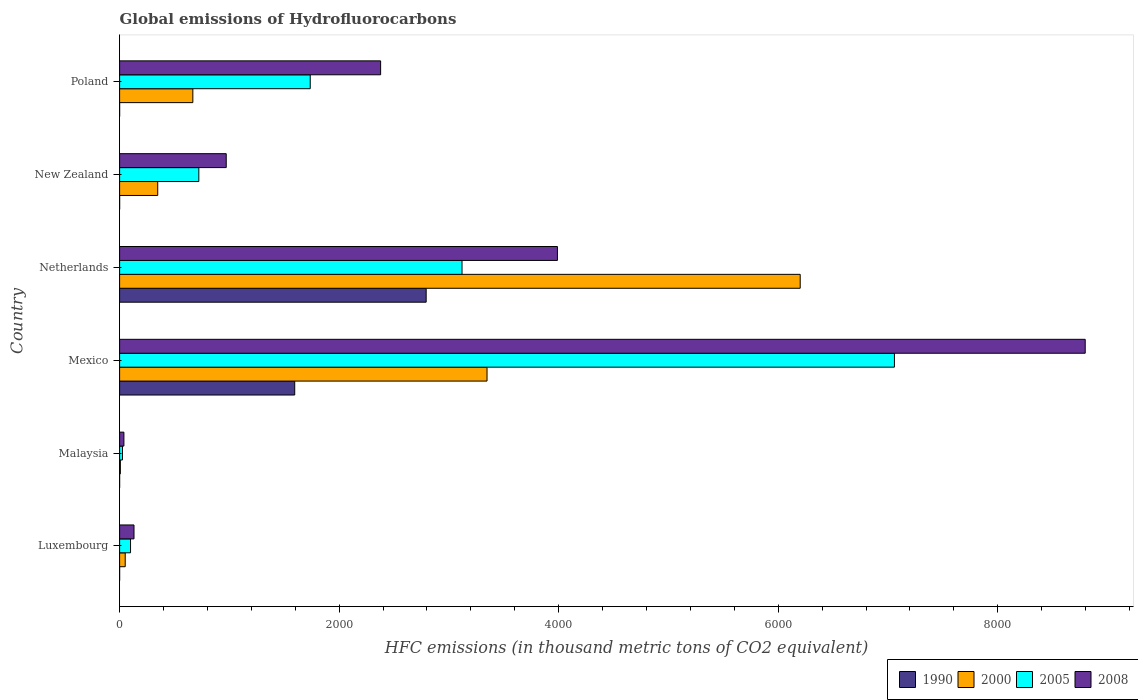What is the label of the 2nd group of bars from the top?
Your response must be concise. New Zealand. What is the global emissions of Hydrofluorocarbons in 2005 in New Zealand?
Provide a succinct answer. 721.7. Across all countries, what is the maximum global emissions of Hydrofluorocarbons in 1990?
Give a very brief answer. 2792.9. In which country was the global emissions of Hydrofluorocarbons in 2005 maximum?
Your response must be concise. Mexico. In which country was the global emissions of Hydrofluorocarbons in 2008 minimum?
Your response must be concise. Malaysia. What is the total global emissions of Hydrofluorocarbons in 2005 in the graph?
Give a very brief answer. 1.28e+04. What is the difference between the global emissions of Hydrofluorocarbons in 2000 in Malaysia and that in New Zealand?
Ensure brevity in your answer.  -340.4. What is the difference between the global emissions of Hydrofluorocarbons in 2005 in Luxembourg and the global emissions of Hydrofluorocarbons in 2000 in New Zealand?
Keep it short and to the point. -247.8. What is the average global emissions of Hydrofluorocarbons in 1990 per country?
Make the answer very short. 731.45. What is the difference between the global emissions of Hydrofluorocarbons in 2005 and global emissions of Hydrofluorocarbons in 2008 in Malaysia?
Your response must be concise. -13.1. What is the ratio of the global emissions of Hydrofluorocarbons in 2000 in Netherlands to that in New Zealand?
Offer a very short reply. 17.85. What is the difference between the highest and the second highest global emissions of Hydrofluorocarbons in 1990?
Your answer should be compact. 1197.6. What is the difference between the highest and the lowest global emissions of Hydrofluorocarbons in 1990?
Your answer should be very brief. 2792.8. In how many countries, is the global emissions of Hydrofluorocarbons in 2008 greater than the average global emissions of Hydrofluorocarbons in 2008 taken over all countries?
Your answer should be very brief. 2. Is the sum of the global emissions of Hydrofluorocarbons in 2008 in Netherlands and Poland greater than the maximum global emissions of Hydrofluorocarbons in 2000 across all countries?
Your answer should be compact. Yes. Is it the case that in every country, the sum of the global emissions of Hydrofluorocarbons in 2008 and global emissions of Hydrofluorocarbons in 2000 is greater than the sum of global emissions of Hydrofluorocarbons in 1990 and global emissions of Hydrofluorocarbons in 2005?
Your response must be concise. No. What does the 1st bar from the top in New Zealand represents?
Give a very brief answer. 2008. How many bars are there?
Provide a succinct answer. 24. Are all the bars in the graph horizontal?
Offer a terse response. Yes. How many countries are there in the graph?
Keep it short and to the point. 6. Are the values on the major ticks of X-axis written in scientific E-notation?
Offer a very short reply. No. Where does the legend appear in the graph?
Your answer should be very brief. Bottom right. How are the legend labels stacked?
Ensure brevity in your answer.  Horizontal. What is the title of the graph?
Keep it short and to the point. Global emissions of Hydrofluorocarbons. Does "2002" appear as one of the legend labels in the graph?
Your response must be concise. No. What is the label or title of the X-axis?
Your answer should be compact. HFC emissions (in thousand metric tons of CO2 equivalent). What is the HFC emissions (in thousand metric tons of CO2 equivalent) in 1990 in Luxembourg?
Your answer should be very brief. 0.1. What is the HFC emissions (in thousand metric tons of CO2 equivalent) of 2000 in Luxembourg?
Your response must be concise. 51.1. What is the HFC emissions (in thousand metric tons of CO2 equivalent) of 2005 in Luxembourg?
Your answer should be very brief. 99.5. What is the HFC emissions (in thousand metric tons of CO2 equivalent) in 2008 in Luxembourg?
Give a very brief answer. 131.2. What is the HFC emissions (in thousand metric tons of CO2 equivalent) in 1990 in Malaysia?
Provide a short and direct response. 0.1. What is the HFC emissions (in thousand metric tons of CO2 equivalent) of 2005 in Malaysia?
Provide a succinct answer. 26.1. What is the HFC emissions (in thousand metric tons of CO2 equivalent) of 2008 in Malaysia?
Ensure brevity in your answer.  39.2. What is the HFC emissions (in thousand metric tons of CO2 equivalent) in 1990 in Mexico?
Give a very brief answer. 1595.3. What is the HFC emissions (in thousand metric tons of CO2 equivalent) of 2000 in Mexico?
Provide a short and direct response. 3347.3. What is the HFC emissions (in thousand metric tons of CO2 equivalent) in 2005 in Mexico?
Give a very brief answer. 7058.9. What is the HFC emissions (in thousand metric tons of CO2 equivalent) of 2008 in Mexico?
Provide a short and direct response. 8796.9. What is the HFC emissions (in thousand metric tons of CO2 equivalent) of 1990 in Netherlands?
Make the answer very short. 2792.9. What is the HFC emissions (in thousand metric tons of CO2 equivalent) in 2000 in Netherlands?
Keep it short and to the point. 6200.4. What is the HFC emissions (in thousand metric tons of CO2 equivalent) of 2005 in Netherlands?
Your response must be concise. 3119.5. What is the HFC emissions (in thousand metric tons of CO2 equivalent) of 2008 in Netherlands?
Offer a terse response. 3988.8. What is the HFC emissions (in thousand metric tons of CO2 equivalent) in 2000 in New Zealand?
Give a very brief answer. 347.3. What is the HFC emissions (in thousand metric tons of CO2 equivalent) of 2005 in New Zealand?
Your answer should be very brief. 721.7. What is the HFC emissions (in thousand metric tons of CO2 equivalent) of 2008 in New Zealand?
Your answer should be very brief. 971.4. What is the HFC emissions (in thousand metric tons of CO2 equivalent) in 2000 in Poland?
Offer a terse response. 667.2. What is the HFC emissions (in thousand metric tons of CO2 equivalent) of 2005 in Poland?
Give a very brief answer. 1736.7. What is the HFC emissions (in thousand metric tons of CO2 equivalent) in 2008 in Poland?
Your answer should be compact. 2378. Across all countries, what is the maximum HFC emissions (in thousand metric tons of CO2 equivalent) of 1990?
Give a very brief answer. 2792.9. Across all countries, what is the maximum HFC emissions (in thousand metric tons of CO2 equivalent) in 2000?
Ensure brevity in your answer.  6200.4. Across all countries, what is the maximum HFC emissions (in thousand metric tons of CO2 equivalent) in 2005?
Make the answer very short. 7058.9. Across all countries, what is the maximum HFC emissions (in thousand metric tons of CO2 equivalent) in 2008?
Your response must be concise. 8796.9. Across all countries, what is the minimum HFC emissions (in thousand metric tons of CO2 equivalent) of 2005?
Your response must be concise. 26.1. Across all countries, what is the minimum HFC emissions (in thousand metric tons of CO2 equivalent) of 2008?
Provide a short and direct response. 39.2. What is the total HFC emissions (in thousand metric tons of CO2 equivalent) of 1990 in the graph?
Provide a succinct answer. 4388.7. What is the total HFC emissions (in thousand metric tons of CO2 equivalent) in 2000 in the graph?
Offer a terse response. 1.06e+04. What is the total HFC emissions (in thousand metric tons of CO2 equivalent) of 2005 in the graph?
Ensure brevity in your answer.  1.28e+04. What is the total HFC emissions (in thousand metric tons of CO2 equivalent) in 2008 in the graph?
Offer a terse response. 1.63e+04. What is the difference between the HFC emissions (in thousand metric tons of CO2 equivalent) of 1990 in Luxembourg and that in Malaysia?
Offer a very short reply. 0. What is the difference between the HFC emissions (in thousand metric tons of CO2 equivalent) in 2000 in Luxembourg and that in Malaysia?
Provide a short and direct response. 44.2. What is the difference between the HFC emissions (in thousand metric tons of CO2 equivalent) of 2005 in Luxembourg and that in Malaysia?
Your answer should be compact. 73.4. What is the difference between the HFC emissions (in thousand metric tons of CO2 equivalent) in 2008 in Luxembourg and that in Malaysia?
Your answer should be compact. 92. What is the difference between the HFC emissions (in thousand metric tons of CO2 equivalent) in 1990 in Luxembourg and that in Mexico?
Provide a short and direct response. -1595.2. What is the difference between the HFC emissions (in thousand metric tons of CO2 equivalent) of 2000 in Luxembourg and that in Mexico?
Your answer should be very brief. -3296.2. What is the difference between the HFC emissions (in thousand metric tons of CO2 equivalent) in 2005 in Luxembourg and that in Mexico?
Provide a succinct answer. -6959.4. What is the difference between the HFC emissions (in thousand metric tons of CO2 equivalent) of 2008 in Luxembourg and that in Mexico?
Make the answer very short. -8665.7. What is the difference between the HFC emissions (in thousand metric tons of CO2 equivalent) of 1990 in Luxembourg and that in Netherlands?
Ensure brevity in your answer.  -2792.8. What is the difference between the HFC emissions (in thousand metric tons of CO2 equivalent) in 2000 in Luxembourg and that in Netherlands?
Provide a short and direct response. -6149.3. What is the difference between the HFC emissions (in thousand metric tons of CO2 equivalent) of 2005 in Luxembourg and that in Netherlands?
Provide a short and direct response. -3020. What is the difference between the HFC emissions (in thousand metric tons of CO2 equivalent) of 2008 in Luxembourg and that in Netherlands?
Keep it short and to the point. -3857.6. What is the difference between the HFC emissions (in thousand metric tons of CO2 equivalent) in 2000 in Luxembourg and that in New Zealand?
Offer a very short reply. -296.2. What is the difference between the HFC emissions (in thousand metric tons of CO2 equivalent) of 2005 in Luxembourg and that in New Zealand?
Provide a succinct answer. -622.2. What is the difference between the HFC emissions (in thousand metric tons of CO2 equivalent) in 2008 in Luxembourg and that in New Zealand?
Give a very brief answer. -840.2. What is the difference between the HFC emissions (in thousand metric tons of CO2 equivalent) in 1990 in Luxembourg and that in Poland?
Keep it short and to the point. 0. What is the difference between the HFC emissions (in thousand metric tons of CO2 equivalent) in 2000 in Luxembourg and that in Poland?
Offer a terse response. -616.1. What is the difference between the HFC emissions (in thousand metric tons of CO2 equivalent) of 2005 in Luxembourg and that in Poland?
Provide a succinct answer. -1637.2. What is the difference between the HFC emissions (in thousand metric tons of CO2 equivalent) in 2008 in Luxembourg and that in Poland?
Your response must be concise. -2246.8. What is the difference between the HFC emissions (in thousand metric tons of CO2 equivalent) of 1990 in Malaysia and that in Mexico?
Ensure brevity in your answer.  -1595.2. What is the difference between the HFC emissions (in thousand metric tons of CO2 equivalent) of 2000 in Malaysia and that in Mexico?
Ensure brevity in your answer.  -3340.4. What is the difference between the HFC emissions (in thousand metric tons of CO2 equivalent) in 2005 in Malaysia and that in Mexico?
Your answer should be compact. -7032.8. What is the difference between the HFC emissions (in thousand metric tons of CO2 equivalent) in 2008 in Malaysia and that in Mexico?
Provide a succinct answer. -8757.7. What is the difference between the HFC emissions (in thousand metric tons of CO2 equivalent) in 1990 in Malaysia and that in Netherlands?
Ensure brevity in your answer.  -2792.8. What is the difference between the HFC emissions (in thousand metric tons of CO2 equivalent) of 2000 in Malaysia and that in Netherlands?
Keep it short and to the point. -6193.5. What is the difference between the HFC emissions (in thousand metric tons of CO2 equivalent) of 2005 in Malaysia and that in Netherlands?
Your answer should be compact. -3093.4. What is the difference between the HFC emissions (in thousand metric tons of CO2 equivalent) in 2008 in Malaysia and that in Netherlands?
Provide a succinct answer. -3949.6. What is the difference between the HFC emissions (in thousand metric tons of CO2 equivalent) of 2000 in Malaysia and that in New Zealand?
Keep it short and to the point. -340.4. What is the difference between the HFC emissions (in thousand metric tons of CO2 equivalent) of 2005 in Malaysia and that in New Zealand?
Provide a short and direct response. -695.6. What is the difference between the HFC emissions (in thousand metric tons of CO2 equivalent) in 2008 in Malaysia and that in New Zealand?
Ensure brevity in your answer.  -932.2. What is the difference between the HFC emissions (in thousand metric tons of CO2 equivalent) of 2000 in Malaysia and that in Poland?
Offer a terse response. -660.3. What is the difference between the HFC emissions (in thousand metric tons of CO2 equivalent) of 2005 in Malaysia and that in Poland?
Offer a very short reply. -1710.6. What is the difference between the HFC emissions (in thousand metric tons of CO2 equivalent) in 2008 in Malaysia and that in Poland?
Keep it short and to the point. -2338.8. What is the difference between the HFC emissions (in thousand metric tons of CO2 equivalent) of 1990 in Mexico and that in Netherlands?
Provide a short and direct response. -1197.6. What is the difference between the HFC emissions (in thousand metric tons of CO2 equivalent) of 2000 in Mexico and that in Netherlands?
Offer a terse response. -2853.1. What is the difference between the HFC emissions (in thousand metric tons of CO2 equivalent) in 2005 in Mexico and that in Netherlands?
Provide a succinct answer. 3939.4. What is the difference between the HFC emissions (in thousand metric tons of CO2 equivalent) in 2008 in Mexico and that in Netherlands?
Make the answer very short. 4808.1. What is the difference between the HFC emissions (in thousand metric tons of CO2 equivalent) in 1990 in Mexico and that in New Zealand?
Offer a terse response. 1595.1. What is the difference between the HFC emissions (in thousand metric tons of CO2 equivalent) of 2000 in Mexico and that in New Zealand?
Give a very brief answer. 3000. What is the difference between the HFC emissions (in thousand metric tons of CO2 equivalent) of 2005 in Mexico and that in New Zealand?
Your answer should be very brief. 6337.2. What is the difference between the HFC emissions (in thousand metric tons of CO2 equivalent) of 2008 in Mexico and that in New Zealand?
Your response must be concise. 7825.5. What is the difference between the HFC emissions (in thousand metric tons of CO2 equivalent) of 1990 in Mexico and that in Poland?
Your answer should be very brief. 1595.2. What is the difference between the HFC emissions (in thousand metric tons of CO2 equivalent) in 2000 in Mexico and that in Poland?
Your answer should be compact. 2680.1. What is the difference between the HFC emissions (in thousand metric tons of CO2 equivalent) in 2005 in Mexico and that in Poland?
Provide a succinct answer. 5322.2. What is the difference between the HFC emissions (in thousand metric tons of CO2 equivalent) of 2008 in Mexico and that in Poland?
Offer a terse response. 6418.9. What is the difference between the HFC emissions (in thousand metric tons of CO2 equivalent) in 1990 in Netherlands and that in New Zealand?
Offer a terse response. 2792.7. What is the difference between the HFC emissions (in thousand metric tons of CO2 equivalent) of 2000 in Netherlands and that in New Zealand?
Offer a very short reply. 5853.1. What is the difference between the HFC emissions (in thousand metric tons of CO2 equivalent) in 2005 in Netherlands and that in New Zealand?
Keep it short and to the point. 2397.8. What is the difference between the HFC emissions (in thousand metric tons of CO2 equivalent) of 2008 in Netherlands and that in New Zealand?
Ensure brevity in your answer.  3017.4. What is the difference between the HFC emissions (in thousand metric tons of CO2 equivalent) of 1990 in Netherlands and that in Poland?
Your response must be concise. 2792.8. What is the difference between the HFC emissions (in thousand metric tons of CO2 equivalent) of 2000 in Netherlands and that in Poland?
Give a very brief answer. 5533.2. What is the difference between the HFC emissions (in thousand metric tons of CO2 equivalent) in 2005 in Netherlands and that in Poland?
Offer a very short reply. 1382.8. What is the difference between the HFC emissions (in thousand metric tons of CO2 equivalent) in 2008 in Netherlands and that in Poland?
Your response must be concise. 1610.8. What is the difference between the HFC emissions (in thousand metric tons of CO2 equivalent) of 2000 in New Zealand and that in Poland?
Provide a short and direct response. -319.9. What is the difference between the HFC emissions (in thousand metric tons of CO2 equivalent) of 2005 in New Zealand and that in Poland?
Ensure brevity in your answer.  -1015. What is the difference between the HFC emissions (in thousand metric tons of CO2 equivalent) of 2008 in New Zealand and that in Poland?
Your response must be concise. -1406.6. What is the difference between the HFC emissions (in thousand metric tons of CO2 equivalent) of 1990 in Luxembourg and the HFC emissions (in thousand metric tons of CO2 equivalent) of 2000 in Malaysia?
Give a very brief answer. -6.8. What is the difference between the HFC emissions (in thousand metric tons of CO2 equivalent) in 1990 in Luxembourg and the HFC emissions (in thousand metric tons of CO2 equivalent) in 2005 in Malaysia?
Your answer should be compact. -26. What is the difference between the HFC emissions (in thousand metric tons of CO2 equivalent) of 1990 in Luxembourg and the HFC emissions (in thousand metric tons of CO2 equivalent) of 2008 in Malaysia?
Keep it short and to the point. -39.1. What is the difference between the HFC emissions (in thousand metric tons of CO2 equivalent) of 2000 in Luxembourg and the HFC emissions (in thousand metric tons of CO2 equivalent) of 2005 in Malaysia?
Make the answer very short. 25. What is the difference between the HFC emissions (in thousand metric tons of CO2 equivalent) in 2005 in Luxembourg and the HFC emissions (in thousand metric tons of CO2 equivalent) in 2008 in Malaysia?
Provide a short and direct response. 60.3. What is the difference between the HFC emissions (in thousand metric tons of CO2 equivalent) of 1990 in Luxembourg and the HFC emissions (in thousand metric tons of CO2 equivalent) of 2000 in Mexico?
Offer a terse response. -3347.2. What is the difference between the HFC emissions (in thousand metric tons of CO2 equivalent) of 1990 in Luxembourg and the HFC emissions (in thousand metric tons of CO2 equivalent) of 2005 in Mexico?
Make the answer very short. -7058.8. What is the difference between the HFC emissions (in thousand metric tons of CO2 equivalent) in 1990 in Luxembourg and the HFC emissions (in thousand metric tons of CO2 equivalent) in 2008 in Mexico?
Offer a very short reply. -8796.8. What is the difference between the HFC emissions (in thousand metric tons of CO2 equivalent) of 2000 in Luxembourg and the HFC emissions (in thousand metric tons of CO2 equivalent) of 2005 in Mexico?
Provide a short and direct response. -7007.8. What is the difference between the HFC emissions (in thousand metric tons of CO2 equivalent) of 2000 in Luxembourg and the HFC emissions (in thousand metric tons of CO2 equivalent) of 2008 in Mexico?
Ensure brevity in your answer.  -8745.8. What is the difference between the HFC emissions (in thousand metric tons of CO2 equivalent) of 2005 in Luxembourg and the HFC emissions (in thousand metric tons of CO2 equivalent) of 2008 in Mexico?
Make the answer very short. -8697.4. What is the difference between the HFC emissions (in thousand metric tons of CO2 equivalent) in 1990 in Luxembourg and the HFC emissions (in thousand metric tons of CO2 equivalent) in 2000 in Netherlands?
Make the answer very short. -6200.3. What is the difference between the HFC emissions (in thousand metric tons of CO2 equivalent) of 1990 in Luxembourg and the HFC emissions (in thousand metric tons of CO2 equivalent) of 2005 in Netherlands?
Keep it short and to the point. -3119.4. What is the difference between the HFC emissions (in thousand metric tons of CO2 equivalent) in 1990 in Luxembourg and the HFC emissions (in thousand metric tons of CO2 equivalent) in 2008 in Netherlands?
Your answer should be compact. -3988.7. What is the difference between the HFC emissions (in thousand metric tons of CO2 equivalent) in 2000 in Luxembourg and the HFC emissions (in thousand metric tons of CO2 equivalent) in 2005 in Netherlands?
Make the answer very short. -3068.4. What is the difference between the HFC emissions (in thousand metric tons of CO2 equivalent) of 2000 in Luxembourg and the HFC emissions (in thousand metric tons of CO2 equivalent) of 2008 in Netherlands?
Provide a succinct answer. -3937.7. What is the difference between the HFC emissions (in thousand metric tons of CO2 equivalent) in 2005 in Luxembourg and the HFC emissions (in thousand metric tons of CO2 equivalent) in 2008 in Netherlands?
Make the answer very short. -3889.3. What is the difference between the HFC emissions (in thousand metric tons of CO2 equivalent) in 1990 in Luxembourg and the HFC emissions (in thousand metric tons of CO2 equivalent) in 2000 in New Zealand?
Provide a short and direct response. -347.2. What is the difference between the HFC emissions (in thousand metric tons of CO2 equivalent) in 1990 in Luxembourg and the HFC emissions (in thousand metric tons of CO2 equivalent) in 2005 in New Zealand?
Your response must be concise. -721.6. What is the difference between the HFC emissions (in thousand metric tons of CO2 equivalent) in 1990 in Luxembourg and the HFC emissions (in thousand metric tons of CO2 equivalent) in 2008 in New Zealand?
Offer a very short reply. -971.3. What is the difference between the HFC emissions (in thousand metric tons of CO2 equivalent) of 2000 in Luxembourg and the HFC emissions (in thousand metric tons of CO2 equivalent) of 2005 in New Zealand?
Provide a succinct answer. -670.6. What is the difference between the HFC emissions (in thousand metric tons of CO2 equivalent) of 2000 in Luxembourg and the HFC emissions (in thousand metric tons of CO2 equivalent) of 2008 in New Zealand?
Give a very brief answer. -920.3. What is the difference between the HFC emissions (in thousand metric tons of CO2 equivalent) of 2005 in Luxembourg and the HFC emissions (in thousand metric tons of CO2 equivalent) of 2008 in New Zealand?
Your answer should be compact. -871.9. What is the difference between the HFC emissions (in thousand metric tons of CO2 equivalent) of 1990 in Luxembourg and the HFC emissions (in thousand metric tons of CO2 equivalent) of 2000 in Poland?
Make the answer very short. -667.1. What is the difference between the HFC emissions (in thousand metric tons of CO2 equivalent) of 1990 in Luxembourg and the HFC emissions (in thousand metric tons of CO2 equivalent) of 2005 in Poland?
Provide a short and direct response. -1736.6. What is the difference between the HFC emissions (in thousand metric tons of CO2 equivalent) in 1990 in Luxembourg and the HFC emissions (in thousand metric tons of CO2 equivalent) in 2008 in Poland?
Your response must be concise. -2377.9. What is the difference between the HFC emissions (in thousand metric tons of CO2 equivalent) in 2000 in Luxembourg and the HFC emissions (in thousand metric tons of CO2 equivalent) in 2005 in Poland?
Provide a succinct answer. -1685.6. What is the difference between the HFC emissions (in thousand metric tons of CO2 equivalent) in 2000 in Luxembourg and the HFC emissions (in thousand metric tons of CO2 equivalent) in 2008 in Poland?
Your answer should be compact. -2326.9. What is the difference between the HFC emissions (in thousand metric tons of CO2 equivalent) of 2005 in Luxembourg and the HFC emissions (in thousand metric tons of CO2 equivalent) of 2008 in Poland?
Ensure brevity in your answer.  -2278.5. What is the difference between the HFC emissions (in thousand metric tons of CO2 equivalent) of 1990 in Malaysia and the HFC emissions (in thousand metric tons of CO2 equivalent) of 2000 in Mexico?
Keep it short and to the point. -3347.2. What is the difference between the HFC emissions (in thousand metric tons of CO2 equivalent) of 1990 in Malaysia and the HFC emissions (in thousand metric tons of CO2 equivalent) of 2005 in Mexico?
Provide a succinct answer. -7058.8. What is the difference between the HFC emissions (in thousand metric tons of CO2 equivalent) in 1990 in Malaysia and the HFC emissions (in thousand metric tons of CO2 equivalent) in 2008 in Mexico?
Make the answer very short. -8796.8. What is the difference between the HFC emissions (in thousand metric tons of CO2 equivalent) in 2000 in Malaysia and the HFC emissions (in thousand metric tons of CO2 equivalent) in 2005 in Mexico?
Your answer should be compact. -7052. What is the difference between the HFC emissions (in thousand metric tons of CO2 equivalent) in 2000 in Malaysia and the HFC emissions (in thousand metric tons of CO2 equivalent) in 2008 in Mexico?
Provide a succinct answer. -8790. What is the difference between the HFC emissions (in thousand metric tons of CO2 equivalent) in 2005 in Malaysia and the HFC emissions (in thousand metric tons of CO2 equivalent) in 2008 in Mexico?
Your response must be concise. -8770.8. What is the difference between the HFC emissions (in thousand metric tons of CO2 equivalent) in 1990 in Malaysia and the HFC emissions (in thousand metric tons of CO2 equivalent) in 2000 in Netherlands?
Offer a terse response. -6200.3. What is the difference between the HFC emissions (in thousand metric tons of CO2 equivalent) of 1990 in Malaysia and the HFC emissions (in thousand metric tons of CO2 equivalent) of 2005 in Netherlands?
Offer a very short reply. -3119.4. What is the difference between the HFC emissions (in thousand metric tons of CO2 equivalent) in 1990 in Malaysia and the HFC emissions (in thousand metric tons of CO2 equivalent) in 2008 in Netherlands?
Make the answer very short. -3988.7. What is the difference between the HFC emissions (in thousand metric tons of CO2 equivalent) of 2000 in Malaysia and the HFC emissions (in thousand metric tons of CO2 equivalent) of 2005 in Netherlands?
Your response must be concise. -3112.6. What is the difference between the HFC emissions (in thousand metric tons of CO2 equivalent) of 2000 in Malaysia and the HFC emissions (in thousand metric tons of CO2 equivalent) of 2008 in Netherlands?
Your answer should be very brief. -3981.9. What is the difference between the HFC emissions (in thousand metric tons of CO2 equivalent) of 2005 in Malaysia and the HFC emissions (in thousand metric tons of CO2 equivalent) of 2008 in Netherlands?
Provide a short and direct response. -3962.7. What is the difference between the HFC emissions (in thousand metric tons of CO2 equivalent) in 1990 in Malaysia and the HFC emissions (in thousand metric tons of CO2 equivalent) in 2000 in New Zealand?
Your response must be concise. -347.2. What is the difference between the HFC emissions (in thousand metric tons of CO2 equivalent) of 1990 in Malaysia and the HFC emissions (in thousand metric tons of CO2 equivalent) of 2005 in New Zealand?
Your answer should be very brief. -721.6. What is the difference between the HFC emissions (in thousand metric tons of CO2 equivalent) in 1990 in Malaysia and the HFC emissions (in thousand metric tons of CO2 equivalent) in 2008 in New Zealand?
Your answer should be very brief. -971.3. What is the difference between the HFC emissions (in thousand metric tons of CO2 equivalent) in 2000 in Malaysia and the HFC emissions (in thousand metric tons of CO2 equivalent) in 2005 in New Zealand?
Provide a short and direct response. -714.8. What is the difference between the HFC emissions (in thousand metric tons of CO2 equivalent) in 2000 in Malaysia and the HFC emissions (in thousand metric tons of CO2 equivalent) in 2008 in New Zealand?
Your answer should be compact. -964.5. What is the difference between the HFC emissions (in thousand metric tons of CO2 equivalent) in 2005 in Malaysia and the HFC emissions (in thousand metric tons of CO2 equivalent) in 2008 in New Zealand?
Offer a terse response. -945.3. What is the difference between the HFC emissions (in thousand metric tons of CO2 equivalent) in 1990 in Malaysia and the HFC emissions (in thousand metric tons of CO2 equivalent) in 2000 in Poland?
Your response must be concise. -667.1. What is the difference between the HFC emissions (in thousand metric tons of CO2 equivalent) in 1990 in Malaysia and the HFC emissions (in thousand metric tons of CO2 equivalent) in 2005 in Poland?
Ensure brevity in your answer.  -1736.6. What is the difference between the HFC emissions (in thousand metric tons of CO2 equivalent) in 1990 in Malaysia and the HFC emissions (in thousand metric tons of CO2 equivalent) in 2008 in Poland?
Keep it short and to the point. -2377.9. What is the difference between the HFC emissions (in thousand metric tons of CO2 equivalent) in 2000 in Malaysia and the HFC emissions (in thousand metric tons of CO2 equivalent) in 2005 in Poland?
Make the answer very short. -1729.8. What is the difference between the HFC emissions (in thousand metric tons of CO2 equivalent) in 2000 in Malaysia and the HFC emissions (in thousand metric tons of CO2 equivalent) in 2008 in Poland?
Make the answer very short. -2371.1. What is the difference between the HFC emissions (in thousand metric tons of CO2 equivalent) of 2005 in Malaysia and the HFC emissions (in thousand metric tons of CO2 equivalent) of 2008 in Poland?
Make the answer very short. -2351.9. What is the difference between the HFC emissions (in thousand metric tons of CO2 equivalent) of 1990 in Mexico and the HFC emissions (in thousand metric tons of CO2 equivalent) of 2000 in Netherlands?
Your answer should be very brief. -4605.1. What is the difference between the HFC emissions (in thousand metric tons of CO2 equivalent) of 1990 in Mexico and the HFC emissions (in thousand metric tons of CO2 equivalent) of 2005 in Netherlands?
Give a very brief answer. -1524.2. What is the difference between the HFC emissions (in thousand metric tons of CO2 equivalent) in 1990 in Mexico and the HFC emissions (in thousand metric tons of CO2 equivalent) in 2008 in Netherlands?
Offer a terse response. -2393.5. What is the difference between the HFC emissions (in thousand metric tons of CO2 equivalent) of 2000 in Mexico and the HFC emissions (in thousand metric tons of CO2 equivalent) of 2005 in Netherlands?
Your answer should be compact. 227.8. What is the difference between the HFC emissions (in thousand metric tons of CO2 equivalent) of 2000 in Mexico and the HFC emissions (in thousand metric tons of CO2 equivalent) of 2008 in Netherlands?
Provide a succinct answer. -641.5. What is the difference between the HFC emissions (in thousand metric tons of CO2 equivalent) in 2005 in Mexico and the HFC emissions (in thousand metric tons of CO2 equivalent) in 2008 in Netherlands?
Ensure brevity in your answer.  3070.1. What is the difference between the HFC emissions (in thousand metric tons of CO2 equivalent) in 1990 in Mexico and the HFC emissions (in thousand metric tons of CO2 equivalent) in 2000 in New Zealand?
Provide a succinct answer. 1248. What is the difference between the HFC emissions (in thousand metric tons of CO2 equivalent) in 1990 in Mexico and the HFC emissions (in thousand metric tons of CO2 equivalent) in 2005 in New Zealand?
Ensure brevity in your answer.  873.6. What is the difference between the HFC emissions (in thousand metric tons of CO2 equivalent) of 1990 in Mexico and the HFC emissions (in thousand metric tons of CO2 equivalent) of 2008 in New Zealand?
Offer a terse response. 623.9. What is the difference between the HFC emissions (in thousand metric tons of CO2 equivalent) in 2000 in Mexico and the HFC emissions (in thousand metric tons of CO2 equivalent) in 2005 in New Zealand?
Offer a terse response. 2625.6. What is the difference between the HFC emissions (in thousand metric tons of CO2 equivalent) of 2000 in Mexico and the HFC emissions (in thousand metric tons of CO2 equivalent) of 2008 in New Zealand?
Ensure brevity in your answer.  2375.9. What is the difference between the HFC emissions (in thousand metric tons of CO2 equivalent) in 2005 in Mexico and the HFC emissions (in thousand metric tons of CO2 equivalent) in 2008 in New Zealand?
Provide a succinct answer. 6087.5. What is the difference between the HFC emissions (in thousand metric tons of CO2 equivalent) in 1990 in Mexico and the HFC emissions (in thousand metric tons of CO2 equivalent) in 2000 in Poland?
Make the answer very short. 928.1. What is the difference between the HFC emissions (in thousand metric tons of CO2 equivalent) of 1990 in Mexico and the HFC emissions (in thousand metric tons of CO2 equivalent) of 2005 in Poland?
Offer a very short reply. -141.4. What is the difference between the HFC emissions (in thousand metric tons of CO2 equivalent) in 1990 in Mexico and the HFC emissions (in thousand metric tons of CO2 equivalent) in 2008 in Poland?
Make the answer very short. -782.7. What is the difference between the HFC emissions (in thousand metric tons of CO2 equivalent) of 2000 in Mexico and the HFC emissions (in thousand metric tons of CO2 equivalent) of 2005 in Poland?
Provide a succinct answer. 1610.6. What is the difference between the HFC emissions (in thousand metric tons of CO2 equivalent) of 2000 in Mexico and the HFC emissions (in thousand metric tons of CO2 equivalent) of 2008 in Poland?
Provide a short and direct response. 969.3. What is the difference between the HFC emissions (in thousand metric tons of CO2 equivalent) in 2005 in Mexico and the HFC emissions (in thousand metric tons of CO2 equivalent) in 2008 in Poland?
Keep it short and to the point. 4680.9. What is the difference between the HFC emissions (in thousand metric tons of CO2 equivalent) of 1990 in Netherlands and the HFC emissions (in thousand metric tons of CO2 equivalent) of 2000 in New Zealand?
Offer a very short reply. 2445.6. What is the difference between the HFC emissions (in thousand metric tons of CO2 equivalent) in 1990 in Netherlands and the HFC emissions (in thousand metric tons of CO2 equivalent) in 2005 in New Zealand?
Give a very brief answer. 2071.2. What is the difference between the HFC emissions (in thousand metric tons of CO2 equivalent) in 1990 in Netherlands and the HFC emissions (in thousand metric tons of CO2 equivalent) in 2008 in New Zealand?
Offer a terse response. 1821.5. What is the difference between the HFC emissions (in thousand metric tons of CO2 equivalent) in 2000 in Netherlands and the HFC emissions (in thousand metric tons of CO2 equivalent) in 2005 in New Zealand?
Ensure brevity in your answer.  5478.7. What is the difference between the HFC emissions (in thousand metric tons of CO2 equivalent) in 2000 in Netherlands and the HFC emissions (in thousand metric tons of CO2 equivalent) in 2008 in New Zealand?
Offer a very short reply. 5229. What is the difference between the HFC emissions (in thousand metric tons of CO2 equivalent) in 2005 in Netherlands and the HFC emissions (in thousand metric tons of CO2 equivalent) in 2008 in New Zealand?
Provide a succinct answer. 2148.1. What is the difference between the HFC emissions (in thousand metric tons of CO2 equivalent) in 1990 in Netherlands and the HFC emissions (in thousand metric tons of CO2 equivalent) in 2000 in Poland?
Keep it short and to the point. 2125.7. What is the difference between the HFC emissions (in thousand metric tons of CO2 equivalent) in 1990 in Netherlands and the HFC emissions (in thousand metric tons of CO2 equivalent) in 2005 in Poland?
Offer a very short reply. 1056.2. What is the difference between the HFC emissions (in thousand metric tons of CO2 equivalent) in 1990 in Netherlands and the HFC emissions (in thousand metric tons of CO2 equivalent) in 2008 in Poland?
Offer a very short reply. 414.9. What is the difference between the HFC emissions (in thousand metric tons of CO2 equivalent) of 2000 in Netherlands and the HFC emissions (in thousand metric tons of CO2 equivalent) of 2005 in Poland?
Offer a very short reply. 4463.7. What is the difference between the HFC emissions (in thousand metric tons of CO2 equivalent) in 2000 in Netherlands and the HFC emissions (in thousand metric tons of CO2 equivalent) in 2008 in Poland?
Give a very brief answer. 3822.4. What is the difference between the HFC emissions (in thousand metric tons of CO2 equivalent) in 2005 in Netherlands and the HFC emissions (in thousand metric tons of CO2 equivalent) in 2008 in Poland?
Offer a terse response. 741.5. What is the difference between the HFC emissions (in thousand metric tons of CO2 equivalent) of 1990 in New Zealand and the HFC emissions (in thousand metric tons of CO2 equivalent) of 2000 in Poland?
Ensure brevity in your answer.  -667. What is the difference between the HFC emissions (in thousand metric tons of CO2 equivalent) in 1990 in New Zealand and the HFC emissions (in thousand metric tons of CO2 equivalent) in 2005 in Poland?
Provide a succinct answer. -1736.5. What is the difference between the HFC emissions (in thousand metric tons of CO2 equivalent) of 1990 in New Zealand and the HFC emissions (in thousand metric tons of CO2 equivalent) of 2008 in Poland?
Give a very brief answer. -2377.8. What is the difference between the HFC emissions (in thousand metric tons of CO2 equivalent) in 2000 in New Zealand and the HFC emissions (in thousand metric tons of CO2 equivalent) in 2005 in Poland?
Provide a succinct answer. -1389.4. What is the difference between the HFC emissions (in thousand metric tons of CO2 equivalent) of 2000 in New Zealand and the HFC emissions (in thousand metric tons of CO2 equivalent) of 2008 in Poland?
Provide a short and direct response. -2030.7. What is the difference between the HFC emissions (in thousand metric tons of CO2 equivalent) in 2005 in New Zealand and the HFC emissions (in thousand metric tons of CO2 equivalent) in 2008 in Poland?
Your answer should be very brief. -1656.3. What is the average HFC emissions (in thousand metric tons of CO2 equivalent) of 1990 per country?
Make the answer very short. 731.45. What is the average HFC emissions (in thousand metric tons of CO2 equivalent) of 2000 per country?
Give a very brief answer. 1770.03. What is the average HFC emissions (in thousand metric tons of CO2 equivalent) in 2005 per country?
Your answer should be compact. 2127.07. What is the average HFC emissions (in thousand metric tons of CO2 equivalent) in 2008 per country?
Ensure brevity in your answer.  2717.58. What is the difference between the HFC emissions (in thousand metric tons of CO2 equivalent) of 1990 and HFC emissions (in thousand metric tons of CO2 equivalent) of 2000 in Luxembourg?
Provide a short and direct response. -51. What is the difference between the HFC emissions (in thousand metric tons of CO2 equivalent) of 1990 and HFC emissions (in thousand metric tons of CO2 equivalent) of 2005 in Luxembourg?
Offer a terse response. -99.4. What is the difference between the HFC emissions (in thousand metric tons of CO2 equivalent) of 1990 and HFC emissions (in thousand metric tons of CO2 equivalent) of 2008 in Luxembourg?
Keep it short and to the point. -131.1. What is the difference between the HFC emissions (in thousand metric tons of CO2 equivalent) of 2000 and HFC emissions (in thousand metric tons of CO2 equivalent) of 2005 in Luxembourg?
Give a very brief answer. -48.4. What is the difference between the HFC emissions (in thousand metric tons of CO2 equivalent) in 2000 and HFC emissions (in thousand metric tons of CO2 equivalent) in 2008 in Luxembourg?
Provide a short and direct response. -80.1. What is the difference between the HFC emissions (in thousand metric tons of CO2 equivalent) of 2005 and HFC emissions (in thousand metric tons of CO2 equivalent) of 2008 in Luxembourg?
Your answer should be very brief. -31.7. What is the difference between the HFC emissions (in thousand metric tons of CO2 equivalent) of 1990 and HFC emissions (in thousand metric tons of CO2 equivalent) of 2005 in Malaysia?
Make the answer very short. -26. What is the difference between the HFC emissions (in thousand metric tons of CO2 equivalent) in 1990 and HFC emissions (in thousand metric tons of CO2 equivalent) in 2008 in Malaysia?
Make the answer very short. -39.1. What is the difference between the HFC emissions (in thousand metric tons of CO2 equivalent) of 2000 and HFC emissions (in thousand metric tons of CO2 equivalent) of 2005 in Malaysia?
Provide a short and direct response. -19.2. What is the difference between the HFC emissions (in thousand metric tons of CO2 equivalent) in 2000 and HFC emissions (in thousand metric tons of CO2 equivalent) in 2008 in Malaysia?
Provide a short and direct response. -32.3. What is the difference between the HFC emissions (in thousand metric tons of CO2 equivalent) in 1990 and HFC emissions (in thousand metric tons of CO2 equivalent) in 2000 in Mexico?
Offer a terse response. -1752. What is the difference between the HFC emissions (in thousand metric tons of CO2 equivalent) in 1990 and HFC emissions (in thousand metric tons of CO2 equivalent) in 2005 in Mexico?
Give a very brief answer. -5463.6. What is the difference between the HFC emissions (in thousand metric tons of CO2 equivalent) of 1990 and HFC emissions (in thousand metric tons of CO2 equivalent) of 2008 in Mexico?
Give a very brief answer. -7201.6. What is the difference between the HFC emissions (in thousand metric tons of CO2 equivalent) of 2000 and HFC emissions (in thousand metric tons of CO2 equivalent) of 2005 in Mexico?
Your response must be concise. -3711.6. What is the difference between the HFC emissions (in thousand metric tons of CO2 equivalent) of 2000 and HFC emissions (in thousand metric tons of CO2 equivalent) of 2008 in Mexico?
Ensure brevity in your answer.  -5449.6. What is the difference between the HFC emissions (in thousand metric tons of CO2 equivalent) in 2005 and HFC emissions (in thousand metric tons of CO2 equivalent) in 2008 in Mexico?
Your answer should be compact. -1738. What is the difference between the HFC emissions (in thousand metric tons of CO2 equivalent) of 1990 and HFC emissions (in thousand metric tons of CO2 equivalent) of 2000 in Netherlands?
Provide a short and direct response. -3407.5. What is the difference between the HFC emissions (in thousand metric tons of CO2 equivalent) in 1990 and HFC emissions (in thousand metric tons of CO2 equivalent) in 2005 in Netherlands?
Your answer should be compact. -326.6. What is the difference between the HFC emissions (in thousand metric tons of CO2 equivalent) of 1990 and HFC emissions (in thousand metric tons of CO2 equivalent) of 2008 in Netherlands?
Provide a succinct answer. -1195.9. What is the difference between the HFC emissions (in thousand metric tons of CO2 equivalent) of 2000 and HFC emissions (in thousand metric tons of CO2 equivalent) of 2005 in Netherlands?
Offer a terse response. 3080.9. What is the difference between the HFC emissions (in thousand metric tons of CO2 equivalent) of 2000 and HFC emissions (in thousand metric tons of CO2 equivalent) of 2008 in Netherlands?
Offer a terse response. 2211.6. What is the difference between the HFC emissions (in thousand metric tons of CO2 equivalent) of 2005 and HFC emissions (in thousand metric tons of CO2 equivalent) of 2008 in Netherlands?
Your answer should be compact. -869.3. What is the difference between the HFC emissions (in thousand metric tons of CO2 equivalent) in 1990 and HFC emissions (in thousand metric tons of CO2 equivalent) in 2000 in New Zealand?
Make the answer very short. -347.1. What is the difference between the HFC emissions (in thousand metric tons of CO2 equivalent) in 1990 and HFC emissions (in thousand metric tons of CO2 equivalent) in 2005 in New Zealand?
Your answer should be very brief. -721.5. What is the difference between the HFC emissions (in thousand metric tons of CO2 equivalent) in 1990 and HFC emissions (in thousand metric tons of CO2 equivalent) in 2008 in New Zealand?
Give a very brief answer. -971.2. What is the difference between the HFC emissions (in thousand metric tons of CO2 equivalent) of 2000 and HFC emissions (in thousand metric tons of CO2 equivalent) of 2005 in New Zealand?
Keep it short and to the point. -374.4. What is the difference between the HFC emissions (in thousand metric tons of CO2 equivalent) in 2000 and HFC emissions (in thousand metric tons of CO2 equivalent) in 2008 in New Zealand?
Offer a very short reply. -624.1. What is the difference between the HFC emissions (in thousand metric tons of CO2 equivalent) of 2005 and HFC emissions (in thousand metric tons of CO2 equivalent) of 2008 in New Zealand?
Your answer should be very brief. -249.7. What is the difference between the HFC emissions (in thousand metric tons of CO2 equivalent) in 1990 and HFC emissions (in thousand metric tons of CO2 equivalent) in 2000 in Poland?
Your answer should be very brief. -667.1. What is the difference between the HFC emissions (in thousand metric tons of CO2 equivalent) in 1990 and HFC emissions (in thousand metric tons of CO2 equivalent) in 2005 in Poland?
Offer a very short reply. -1736.6. What is the difference between the HFC emissions (in thousand metric tons of CO2 equivalent) of 1990 and HFC emissions (in thousand metric tons of CO2 equivalent) of 2008 in Poland?
Provide a short and direct response. -2377.9. What is the difference between the HFC emissions (in thousand metric tons of CO2 equivalent) in 2000 and HFC emissions (in thousand metric tons of CO2 equivalent) in 2005 in Poland?
Keep it short and to the point. -1069.5. What is the difference between the HFC emissions (in thousand metric tons of CO2 equivalent) of 2000 and HFC emissions (in thousand metric tons of CO2 equivalent) of 2008 in Poland?
Give a very brief answer. -1710.8. What is the difference between the HFC emissions (in thousand metric tons of CO2 equivalent) in 2005 and HFC emissions (in thousand metric tons of CO2 equivalent) in 2008 in Poland?
Ensure brevity in your answer.  -641.3. What is the ratio of the HFC emissions (in thousand metric tons of CO2 equivalent) in 1990 in Luxembourg to that in Malaysia?
Make the answer very short. 1. What is the ratio of the HFC emissions (in thousand metric tons of CO2 equivalent) in 2000 in Luxembourg to that in Malaysia?
Your answer should be compact. 7.41. What is the ratio of the HFC emissions (in thousand metric tons of CO2 equivalent) of 2005 in Luxembourg to that in Malaysia?
Your response must be concise. 3.81. What is the ratio of the HFC emissions (in thousand metric tons of CO2 equivalent) in 2008 in Luxembourg to that in Malaysia?
Keep it short and to the point. 3.35. What is the ratio of the HFC emissions (in thousand metric tons of CO2 equivalent) of 2000 in Luxembourg to that in Mexico?
Ensure brevity in your answer.  0.02. What is the ratio of the HFC emissions (in thousand metric tons of CO2 equivalent) in 2005 in Luxembourg to that in Mexico?
Provide a succinct answer. 0.01. What is the ratio of the HFC emissions (in thousand metric tons of CO2 equivalent) in 2008 in Luxembourg to that in Mexico?
Your answer should be very brief. 0.01. What is the ratio of the HFC emissions (in thousand metric tons of CO2 equivalent) of 2000 in Luxembourg to that in Netherlands?
Offer a terse response. 0.01. What is the ratio of the HFC emissions (in thousand metric tons of CO2 equivalent) in 2005 in Luxembourg to that in Netherlands?
Provide a succinct answer. 0.03. What is the ratio of the HFC emissions (in thousand metric tons of CO2 equivalent) of 2008 in Luxembourg to that in Netherlands?
Offer a terse response. 0.03. What is the ratio of the HFC emissions (in thousand metric tons of CO2 equivalent) in 2000 in Luxembourg to that in New Zealand?
Provide a short and direct response. 0.15. What is the ratio of the HFC emissions (in thousand metric tons of CO2 equivalent) in 2005 in Luxembourg to that in New Zealand?
Keep it short and to the point. 0.14. What is the ratio of the HFC emissions (in thousand metric tons of CO2 equivalent) in 2008 in Luxembourg to that in New Zealand?
Your answer should be very brief. 0.14. What is the ratio of the HFC emissions (in thousand metric tons of CO2 equivalent) of 2000 in Luxembourg to that in Poland?
Offer a very short reply. 0.08. What is the ratio of the HFC emissions (in thousand metric tons of CO2 equivalent) in 2005 in Luxembourg to that in Poland?
Offer a very short reply. 0.06. What is the ratio of the HFC emissions (in thousand metric tons of CO2 equivalent) in 2008 in Luxembourg to that in Poland?
Give a very brief answer. 0.06. What is the ratio of the HFC emissions (in thousand metric tons of CO2 equivalent) of 1990 in Malaysia to that in Mexico?
Keep it short and to the point. 0. What is the ratio of the HFC emissions (in thousand metric tons of CO2 equivalent) in 2000 in Malaysia to that in Mexico?
Keep it short and to the point. 0. What is the ratio of the HFC emissions (in thousand metric tons of CO2 equivalent) in 2005 in Malaysia to that in Mexico?
Keep it short and to the point. 0. What is the ratio of the HFC emissions (in thousand metric tons of CO2 equivalent) of 2008 in Malaysia to that in Mexico?
Make the answer very short. 0. What is the ratio of the HFC emissions (in thousand metric tons of CO2 equivalent) of 1990 in Malaysia to that in Netherlands?
Make the answer very short. 0. What is the ratio of the HFC emissions (in thousand metric tons of CO2 equivalent) in 2000 in Malaysia to that in Netherlands?
Provide a short and direct response. 0. What is the ratio of the HFC emissions (in thousand metric tons of CO2 equivalent) of 2005 in Malaysia to that in Netherlands?
Provide a short and direct response. 0.01. What is the ratio of the HFC emissions (in thousand metric tons of CO2 equivalent) of 2008 in Malaysia to that in Netherlands?
Give a very brief answer. 0.01. What is the ratio of the HFC emissions (in thousand metric tons of CO2 equivalent) of 1990 in Malaysia to that in New Zealand?
Your answer should be very brief. 0.5. What is the ratio of the HFC emissions (in thousand metric tons of CO2 equivalent) of 2000 in Malaysia to that in New Zealand?
Your answer should be compact. 0.02. What is the ratio of the HFC emissions (in thousand metric tons of CO2 equivalent) of 2005 in Malaysia to that in New Zealand?
Ensure brevity in your answer.  0.04. What is the ratio of the HFC emissions (in thousand metric tons of CO2 equivalent) of 2008 in Malaysia to that in New Zealand?
Ensure brevity in your answer.  0.04. What is the ratio of the HFC emissions (in thousand metric tons of CO2 equivalent) of 1990 in Malaysia to that in Poland?
Offer a very short reply. 1. What is the ratio of the HFC emissions (in thousand metric tons of CO2 equivalent) in 2000 in Malaysia to that in Poland?
Your answer should be very brief. 0.01. What is the ratio of the HFC emissions (in thousand metric tons of CO2 equivalent) of 2005 in Malaysia to that in Poland?
Give a very brief answer. 0.01. What is the ratio of the HFC emissions (in thousand metric tons of CO2 equivalent) in 2008 in Malaysia to that in Poland?
Provide a succinct answer. 0.02. What is the ratio of the HFC emissions (in thousand metric tons of CO2 equivalent) of 1990 in Mexico to that in Netherlands?
Offer a terse response. 0.57. What is the ratio of the HFC emissions (in thousand metric tons of CO2 equivalent) in 2000 in Mexico to that in Netherlands?
Offer a very short reply. 0.54. What is the ratio of the HFC emissions (in thousand metric tons of CO2 equivalent) in 2005 in Mexico to that in Netherlands?
Your answer should be compact. 2.26. What is the ratio of the HFC emissions (in thousand metric tons of CO2 equivalent) in 2008 in Mexico to that in Netherlands?
Your answer should be compact. 2.21. What is the ratio of the HFC emissions (in thousand metric tons of CO2 equivalent) in 1990 in Mexico to that in New Zealand?
Give a very brief answer. 7976.5. What is the ratio of the HFC emissions (in thousand metric tons of CO2 equivalent) in 2000 in Mexico to that in New Zealand?
Ensure brevity in your answer.  9.64. What is the ratio of the HFC emissions (in thousand metric tons of CO2 equivalent) of 2005 in Mexico to that in New Zealand?
Offer a terse response. 9.78. What is the ratio of the HFC emissions (in thousand metric tons of CO2 equivalent) in 2008 in Mexico to that in New Zealand?
Offer a very short reply. 9.06. What is the ratio of the HFC emissions (in thousand metric tons of CO2 equivalent) of 1990 in Mexico to that in Poland?
Give a very brief answer. 1.60e+04. What is the ratio of the HFC emissions (in thousand metric tons of CO2 equivalent) of 2000 in Mexico to that in Poland?
Make the answer very short. 5.02. What is the ratio of the HFC emissions (in thousand metric tons of CO2 equivalent) in 2005 in Mexico to that in Poland?
Your answer should be compact. 4.06. What is the ratio of the HFC emissions (in thousand metric tons of CO2 equivalent) of 2008 in Mexico to that in Poland?
Your answer should be very brief. 3.7. What is the ratio of the HFC emissions (in thousand metric tons of CO2 equivalent) in 1990 in Netherlands to that in New Zealand?
Ensure brevity in your answer.  1.40e+04. What is the ratio of the HFC emissions (in thousand metric tons of CO2 equivalent) in 2000 in Netherlands to that in New Zealand?
Offer a very short reply. 17.85. What is the ratio of the HFC emissions (in thousand metric tons of CO2 equivalent) of 2005 in Netherlands to that in New Zealand?
Your answer should be very brief. 4.32. What is the ratio of the HFC emissions (in thousand metric tons of CO2 equivalent) of 2008 in Netherlands to that in New Zealand?
Give a very brief answer. 4.11. What is the ratio of the HFC emissions (in thousand metric tons of CO2 equivalent) in 1990 in Netherlands to that in Poland?
Ensure brevity in your answer.  2.79e+04. What is the ratio of the HFC emissions (in thousand metric tons of CO2 equivalent) of 2000 in Netherlands to that in Poland?
Provide a short and direct response. 9.29. What is the ratio of the HFC emissions (in thousand metric tons of CO2 equivalent) of 2005 in Netherlands to that in Poland?
Give a very brief answer. 1.8. What is the ratio of the HFC emissions (in thousand metric tons of CO2 equivalent) of 2008 in Netherlands to that in Poland?
Give a very brief answer. 1.68. What is the ratio of the HFC emissions (in thousand metric tons of CO2 equivalent) in 1990 in New Zealand to that in Poland?
Provide a succinct answer. 2. What is the ratio of the HFC emissions (in thousand metric tons of CO2 equivalent) of 2000 in New Zealand to that in Poland?
Your answer should be compact. 0.52. What is the ratio of the HFC emissions (in thousand metric tons of CO2 equivalent) in 2005 in New Zealand to that in Poland?
Keep it short and to the point. 0.42. What is the ratio of the HFC emissions (in thousand metric tons of CO2 equivalent) in 2008 in New Zealand to that in Poland?
Offer a very short reply. 0.41. What is the difference between the highest and the second highest HFC emissions (in thousand metric tons of CO2 equivalent) in 1990?
Provide a short and direct response. 1197.6. What is the difference between the highest and the second highest HFC emissions (in thousand metric tons of CO2 equivalent) in 2000?
Your response must be concise. 2853.1. What is the difference between the highest and the second highest HFC emissions (in thousand metric tons of CO2 equivalent) in 2005?
Provide a succinct answer. 3939.4. What is the difference between the highest and the second highest HFC emissions (in thousand metric tons of CO2 equivalent) of 2008?
Ensure brevity in your answer.  4808.1. What is the difference between the highest and the lowest HFC emissions (in thousand metric tons of CO2 equivalent) of 1990?
Make the answer very short. 2792.8. What is the difference between the highest and the lowest HFC emissions (in thousand metric tons of CO2 equivalent) of 2000?
Offer a very short reply. 6193.5. What is the difference between the highest and the lowest HFC emissions (in thousand metric tons of CO2 equivalent) of 2005?
Ensure brevity in your answer.  7032.8. What is the difference between the highest and the lowest HFC emissions (in thousand metric tons of CO2 equivalent) of 2008?
Your response must be concise. 8757.7. 